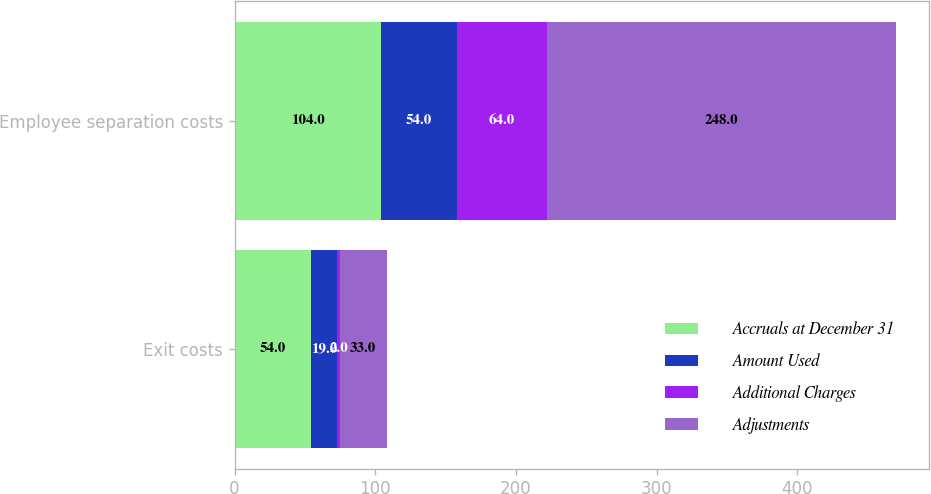Convert chart to OTSL. <chart><loc_0><loc_0><loc_500><loc_500><stacked_bar_chart><ecel><fcel>Exit costs<fcel>Employee separation costs<nl><fcel>Accruals at December 31<fcel>54<fcel>104<nl><fcel>Amount Used<fcel>19<fcel>54<nl><fcel>Additional Charges<fcel>2<fcel>64<nl><fcel>Adjustments<fcel>33<fcel>248<nl></chart> 